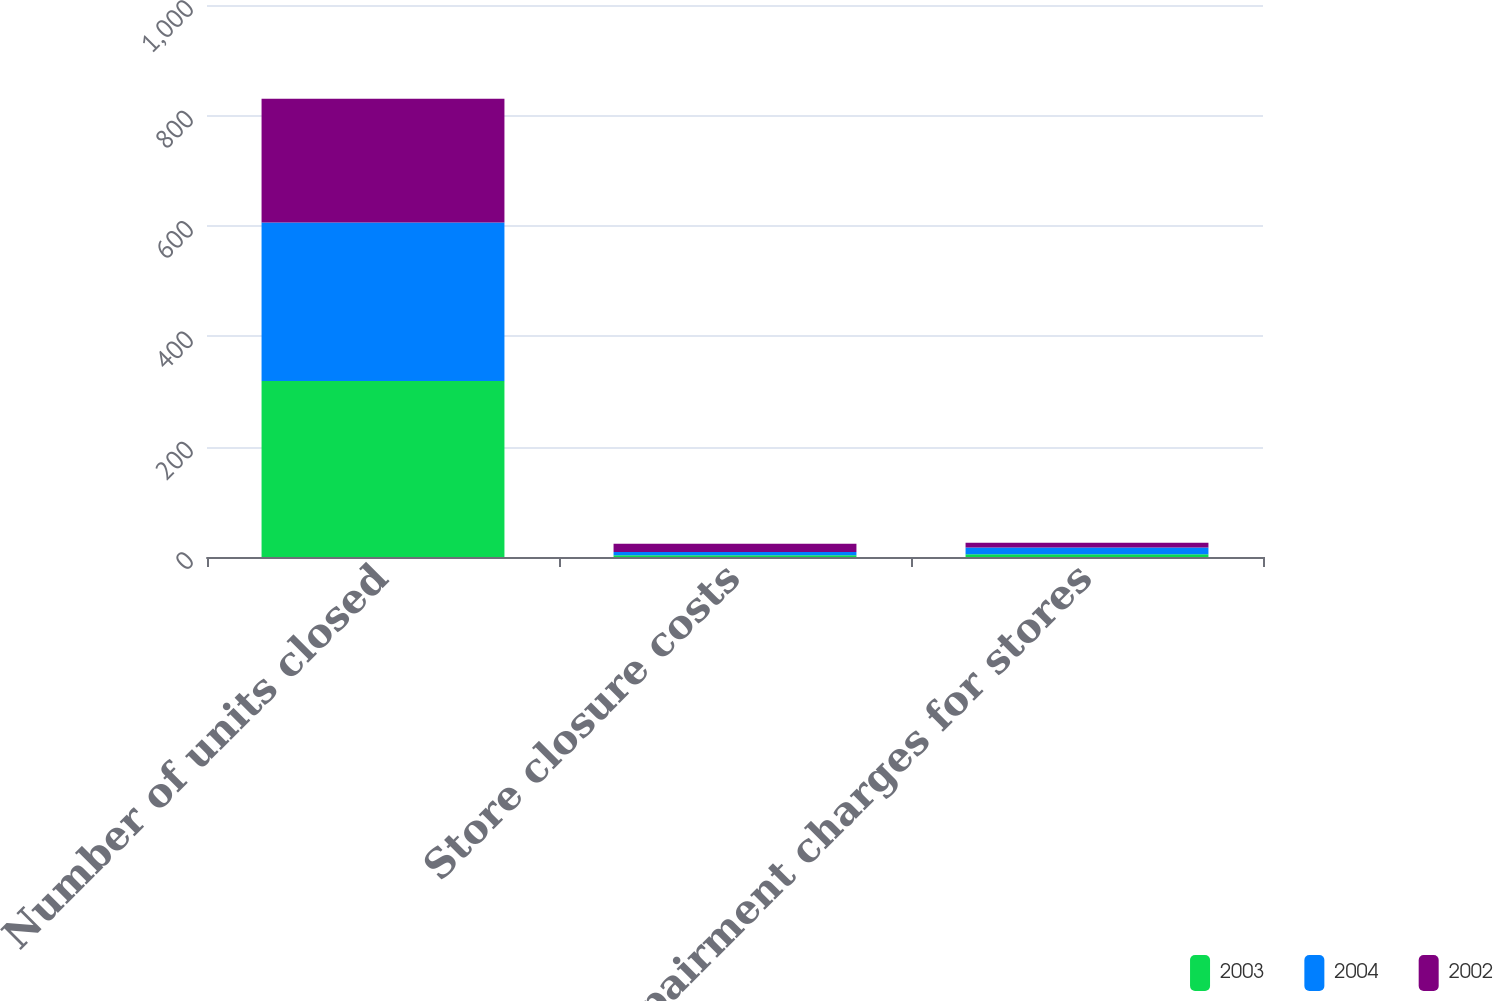<chart> <loc_0><loc_0><loc_500><loc_500><stacked_bar_chart><ecel><fcel>Number of units closed<fcel>Store closure costs<fcel>Impairment charges for stores<nl><fcel>2003<fcel>319<fcel>3<fcel>5<nl><fcel>2004<fcel>287<fcel>6<fcel>12<nl><fcel>2002<fcel>224<fcel>15<fcel>9<nl></chart> 